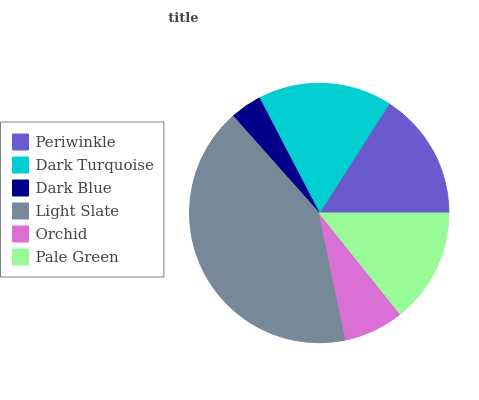Is Dark Blue the minimum?
Answer yes or no. Yes. Is Light Slate the maximum?
Answer yes or no. Yes. Is Dark Turquoise the minimum?
Answer yes or no. No. Is Dark Turquoise the maximum?
Answer yes or no. No. Is Dark Turquoise greater than Periwinkle?
Answer yes or no. Yes. Is Periwinkle less than Dark Turquoise?
Answer yes or no. Yes. Is Periwinkle greater than Dark Turquoise?
Answer yes or no. No. Is Dark Turquoise less than Periwinkle?
Answer yes or no. No. Is Periwinkle the high median?
Answer yes or no. Yes. Is Pale Green the low median?
Answer yes or no. Yes. Is Pale Green the high median?
Answer yes or no. No. Is Dark Blue the low median?
Answer yes or no. No. 